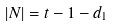<formula> <loc_0><loc_0><loc_500><loc_500>| N | = t - 1 - d _ { 1 }</formula> 